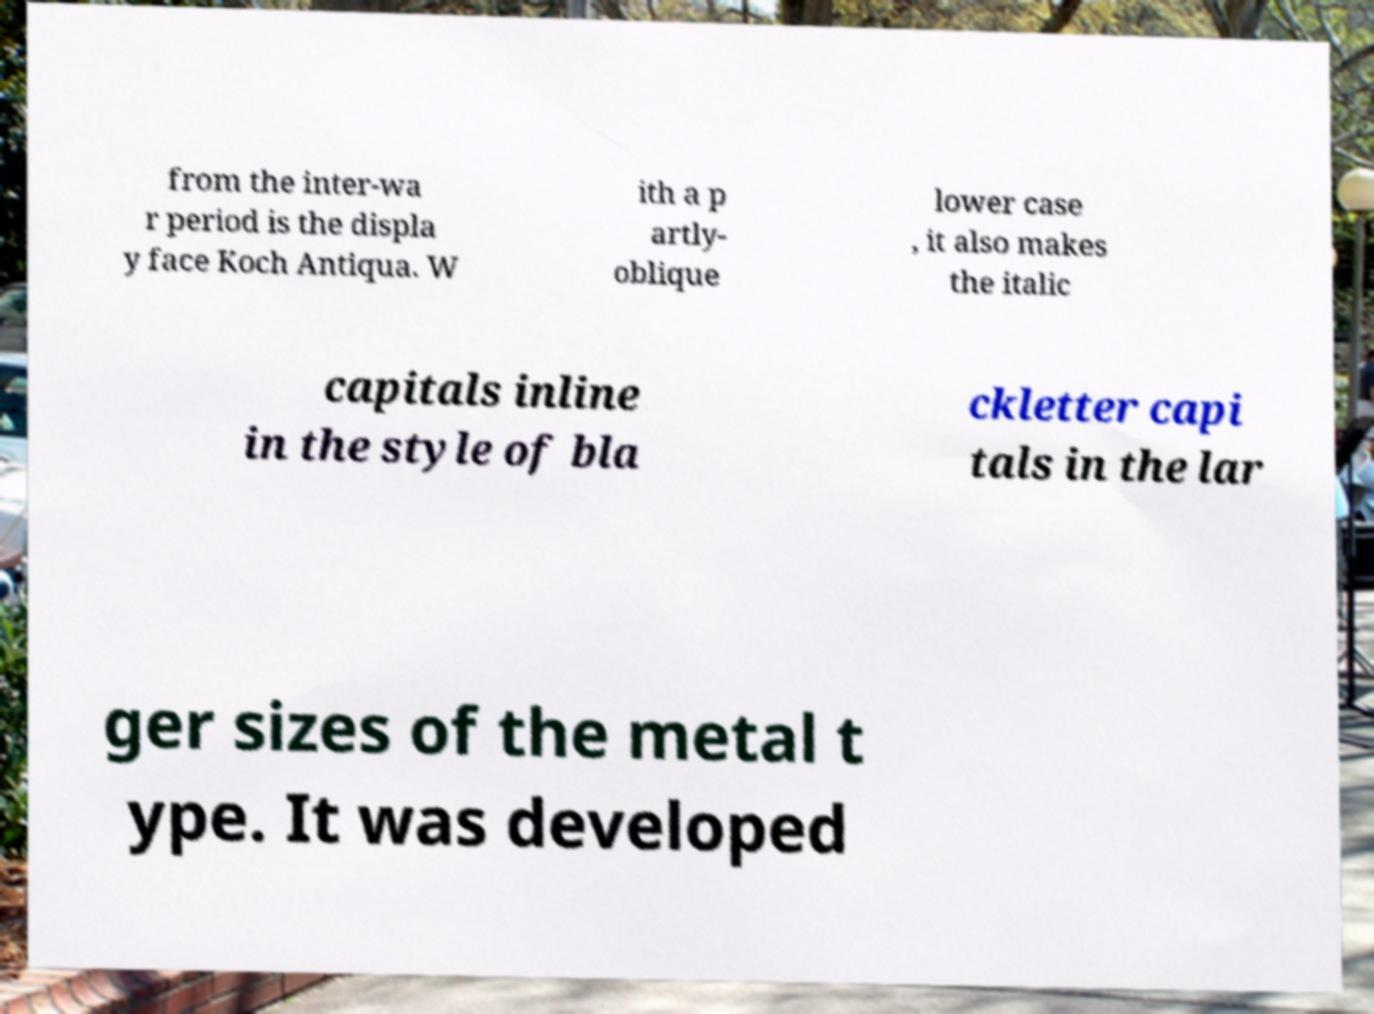Can you accurately transcribe the text from the provided image for me? from the inter-wa r period is the displa y face Koch Antiqua. W ith a p artly- oblique lower case , it also makes the italic capitals inline in the style of bla ckletter capi tals in the lar ger sizes of the metal t ype. It was developed 